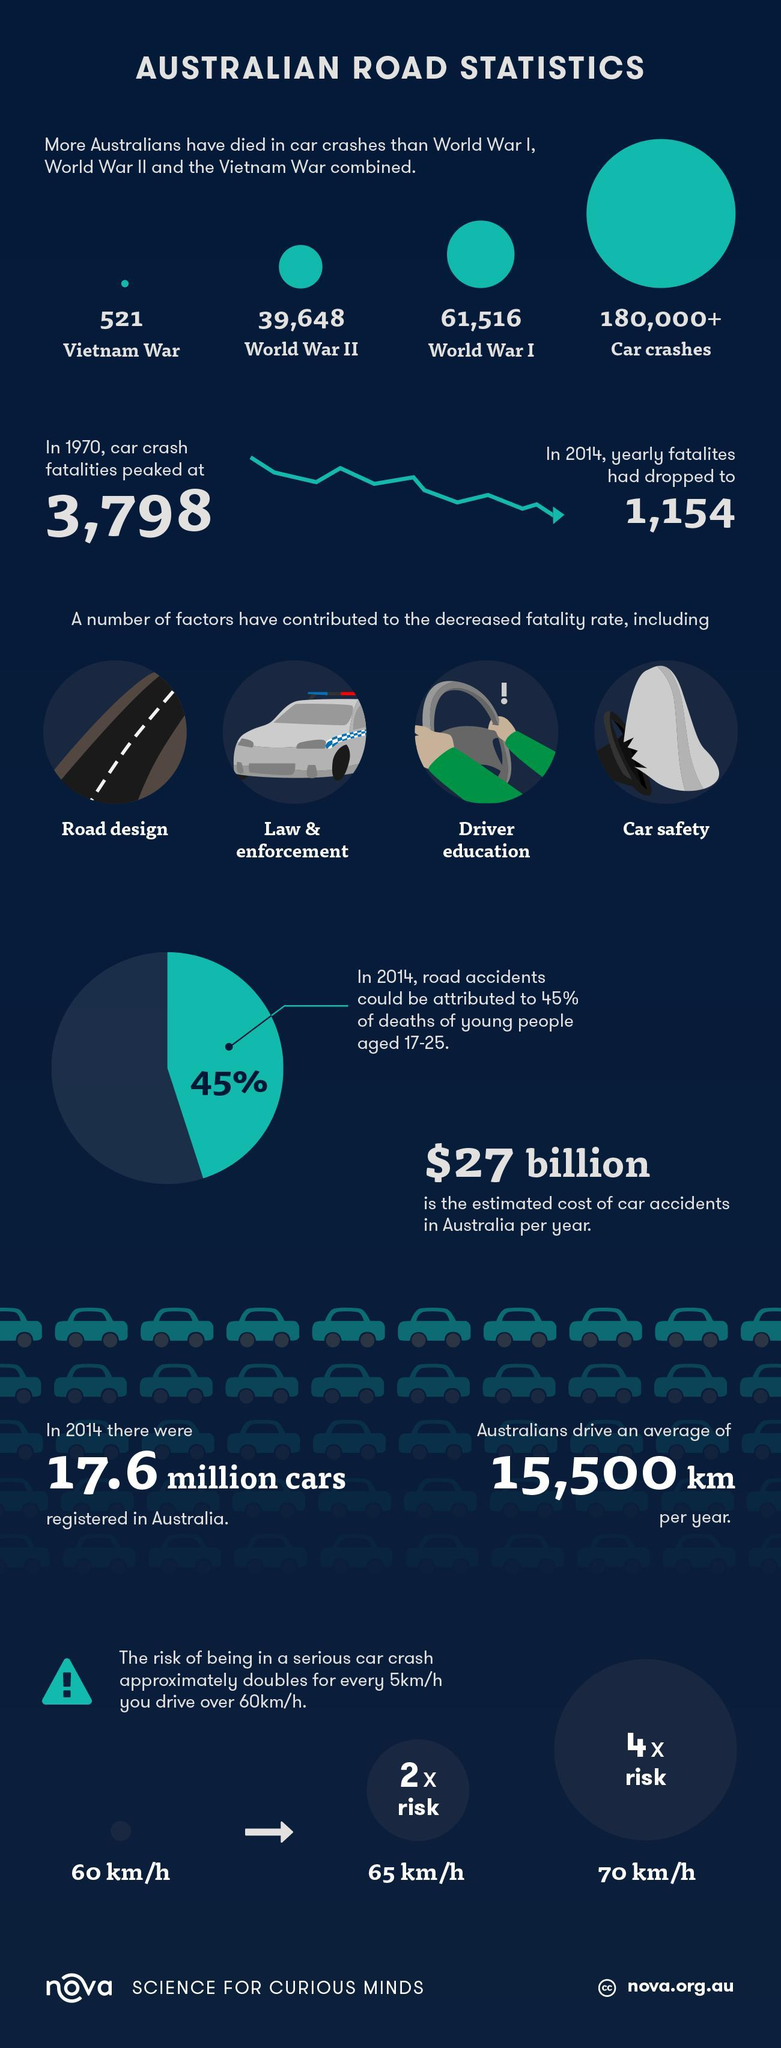what is the difference in crash fatality in 1970 and 2014
Answer the question with a short phrase. 2644 how many have died in vietnam war and world war II 40169 what is the colour of the shirt sleeve, red or green green how much the risk of a serious car crash increase at a speed of 70 km/h 4 x how many have died in world war I 61,516 when did car crash peak 1970 what is a safe speed as per the document 60km/h 